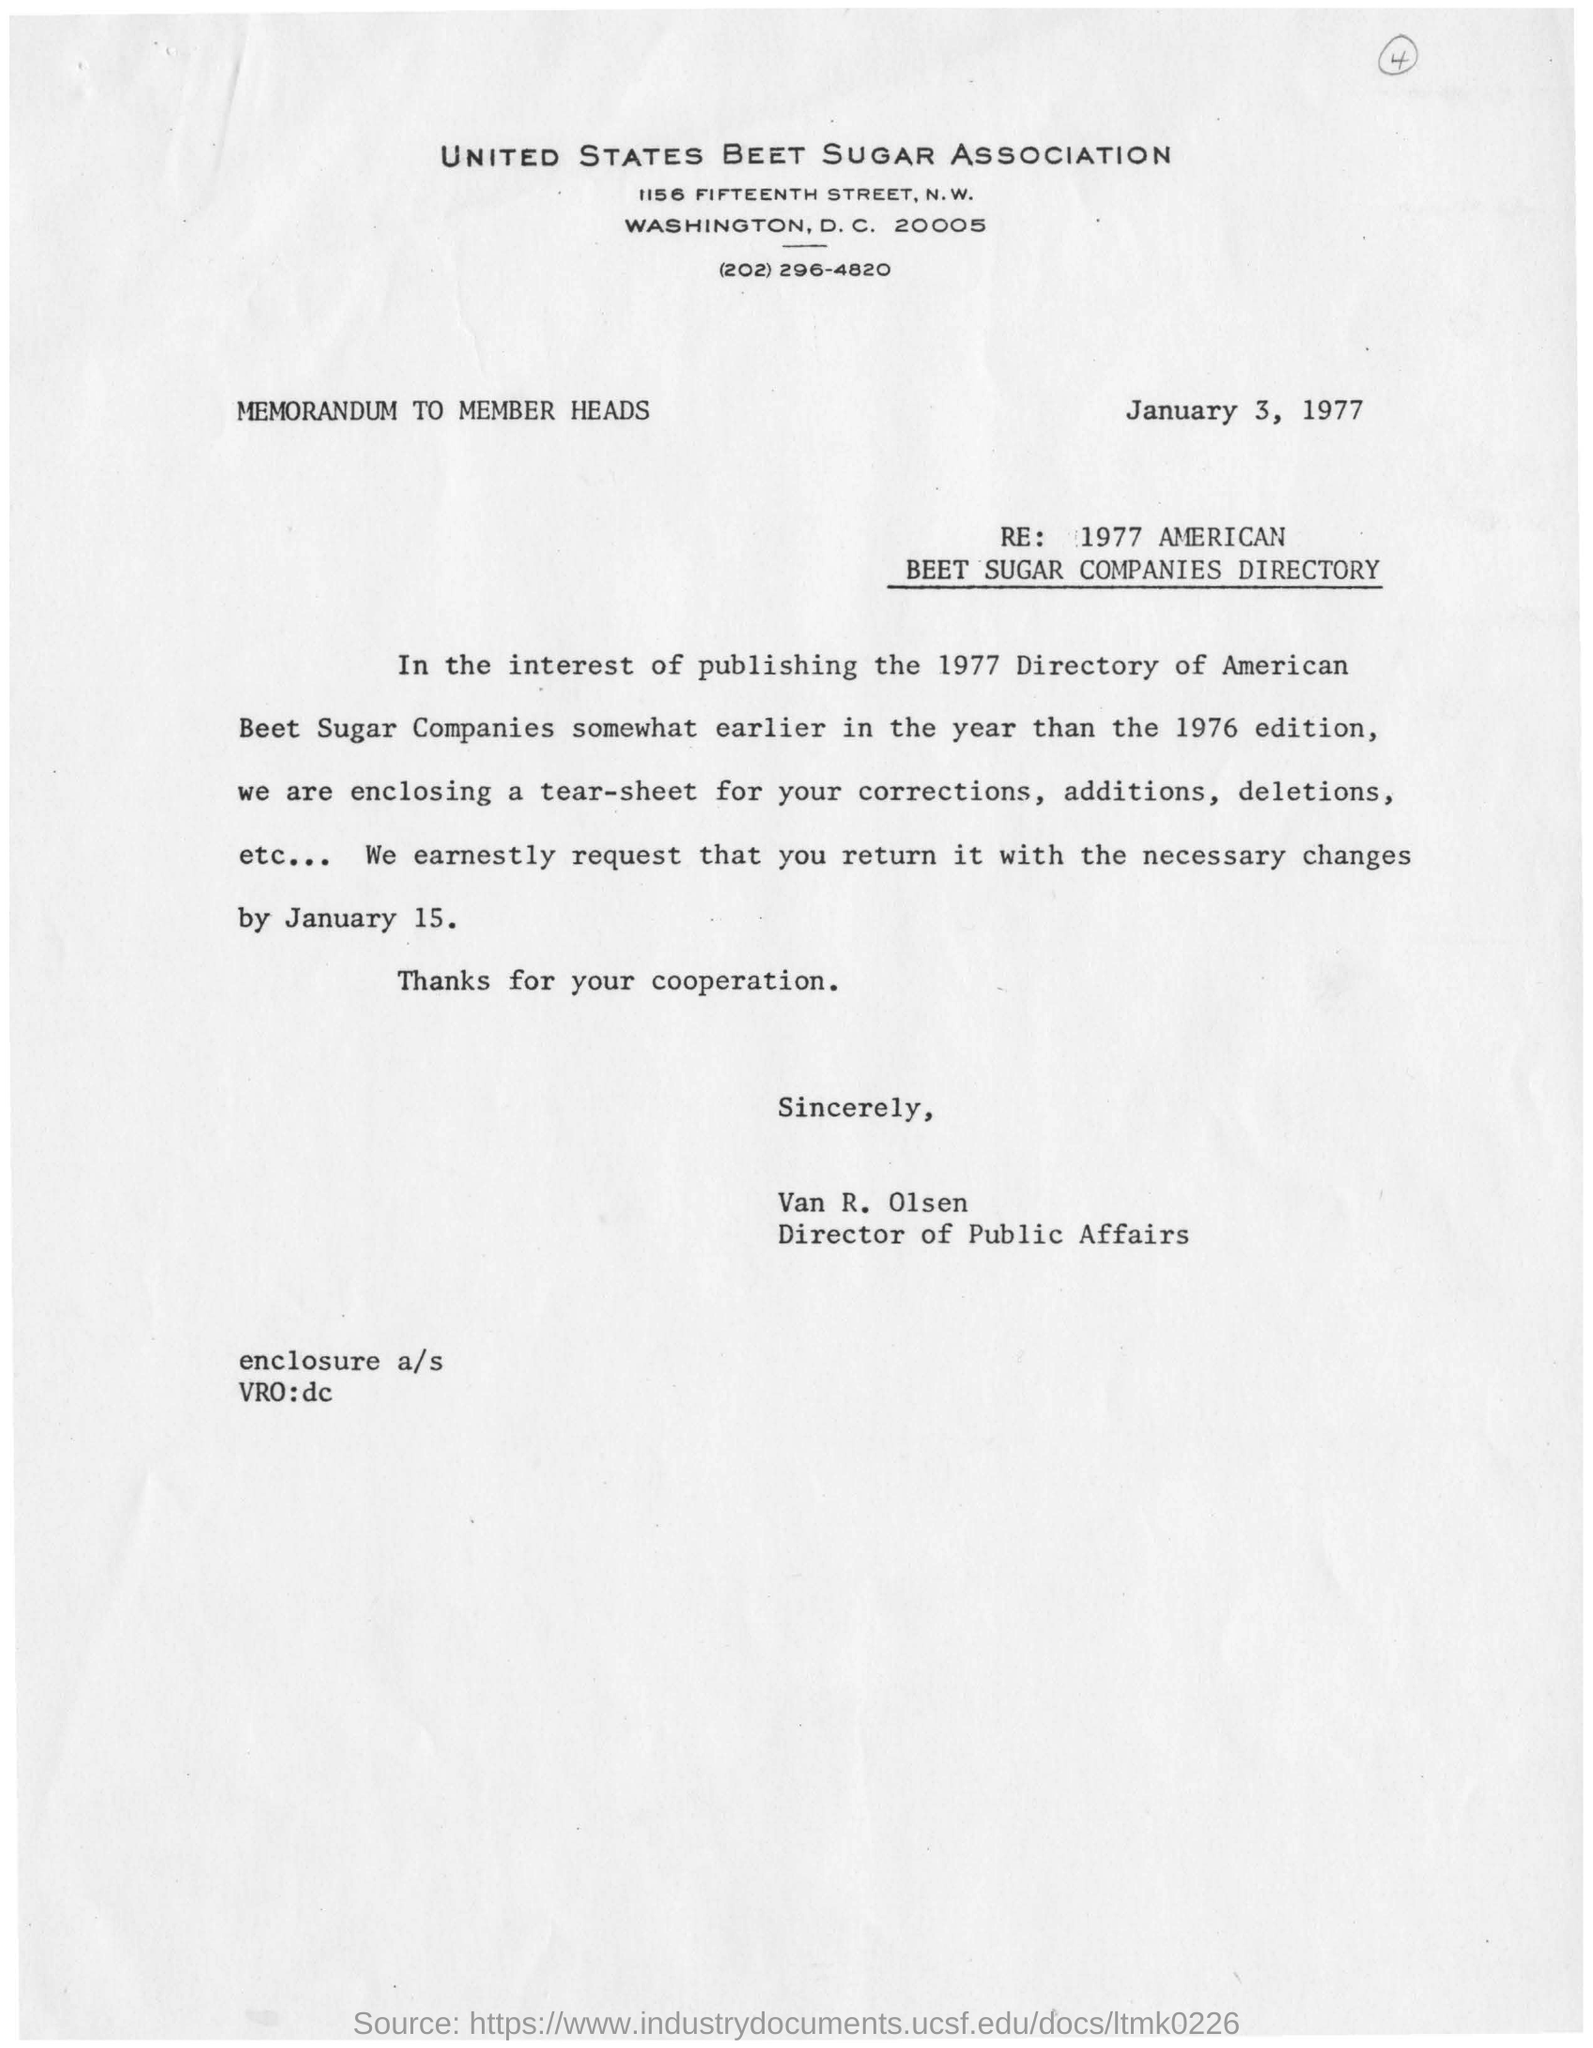Outline some significant characteristics in this image. The person in charge of Public Affairs is VAN R. OLSEN. The publication of the directory is likely to take place in 1977. The purpose of the letter is to include a tear sheet for making corrections, additions, or deletions. The letter is dated January 3, 1977. 